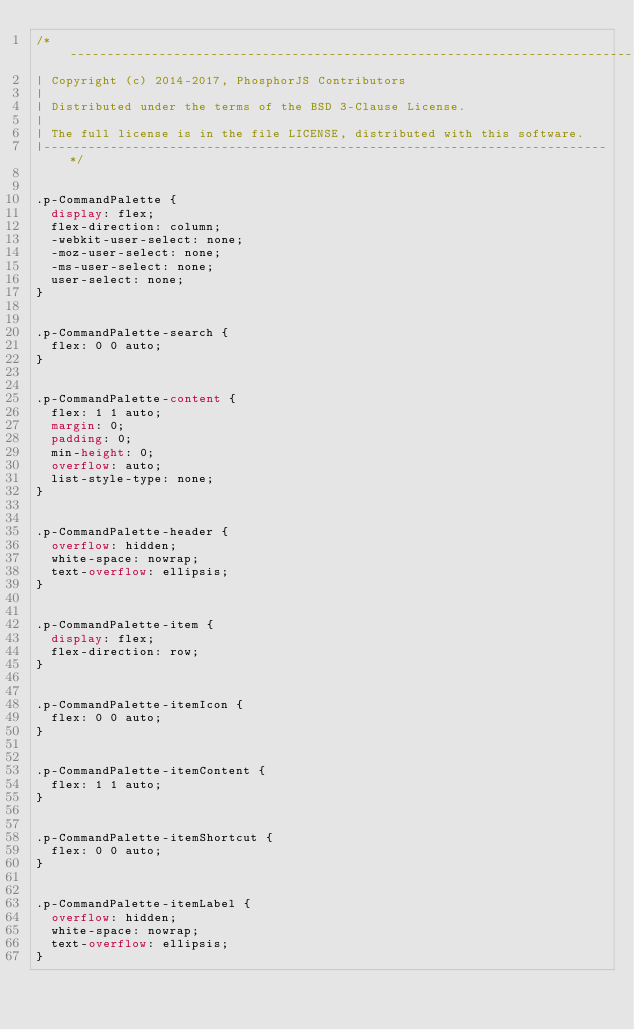Convert code to text. <code><loc_0><loc_0><loc_500><loc_500><_CSS_>/*-----------------------------------------------------------------------------
| Copyright (c) 2014-2017, PhosphorJS Contributors
|
| Distributed under the terms of the BSD 3-Clause License.
|
| The full license is in the file LICENSE, distributed with this software.
|----------------------------------------------------------------------------*/


.p-CommandPalette {
  display: flex;
  flex-direction: column;
  -webkit-user-select: none;
  -moz-user-select: none;
  -ms-user-select: none;
  user-select: none;
}


.p-CommandPalette-search {
  flex: 0 0 auto;
}


.p-CommandPalette-content {
  flex: 1 1 auto;
  margin: 0;
  padding: 0;
  min-height: 0;
  overflow: auto;
  list-style-type: none;
}


.p-CommandPalette-header {
  overflow: hidden;
  white-space: nowrap;
  text-overflow: ellipsis;
}


.p-CommandPalette-item {
  display: flex;
  flex-direction: row;
}


.p-CommandPalette-itemIcon {
  flex: 0 0 auto;
}


.p-CommandPalette-itemContent {
  flex: 1 1 auto;
}


.p-CommandPalette-itemShortcut {
  flex: 0 0 auto;
}


.p-CommandPalette-itemLabel {
  overflow: hidden;
  white-space: nowrap;
  text-overflow: ellipsis;
}
</code> 